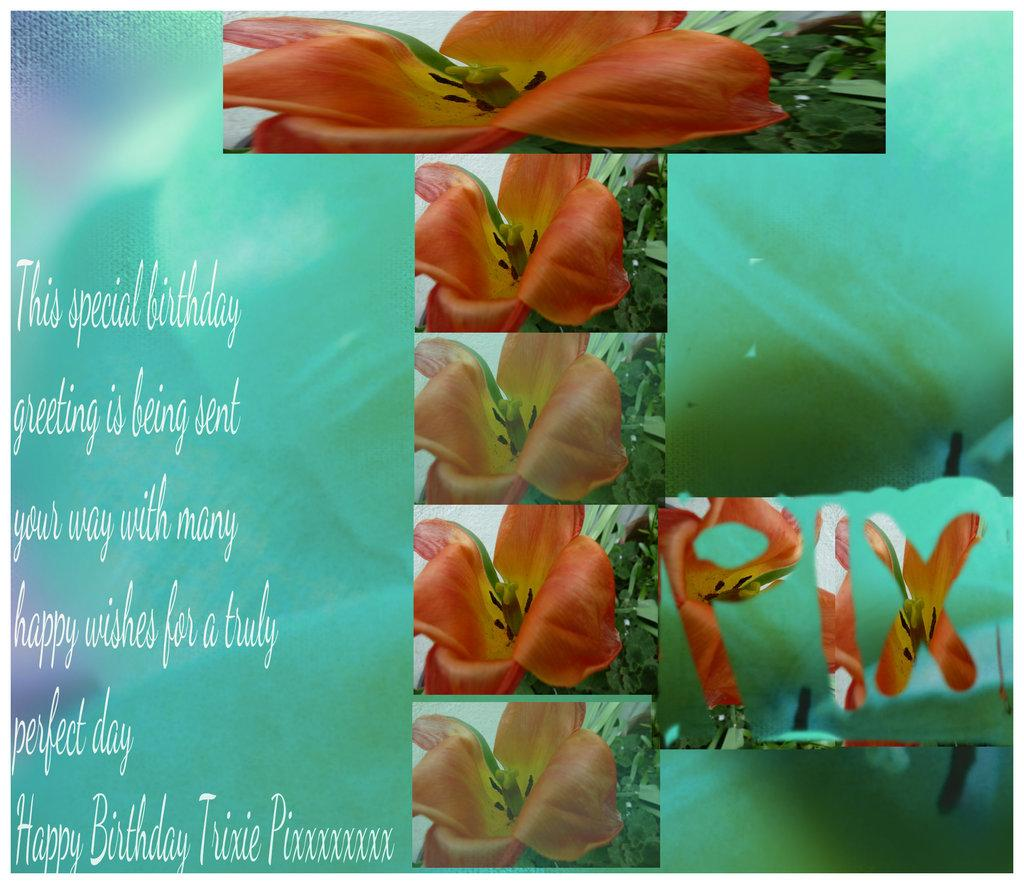What is the main subject of the image? There is a collage of flowers in the image. Are there any words or letters in the image? Yes, there is text visible in the image. What color is the background of the image? The background of the image is green. How many silver items can be seen in the image? There is no silver item present in the image. Can you tell me which flower in the collage has the longest nose? Flowers do not have noses, so this question cannot be answered. 